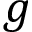<formula> <loc_0><loc_0><loc_500><loc_500>g</formula> 